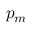Convert formula to latex. <formula><loc_0><loc_0><loc_500><loc_500>p _ { m }</formula> 